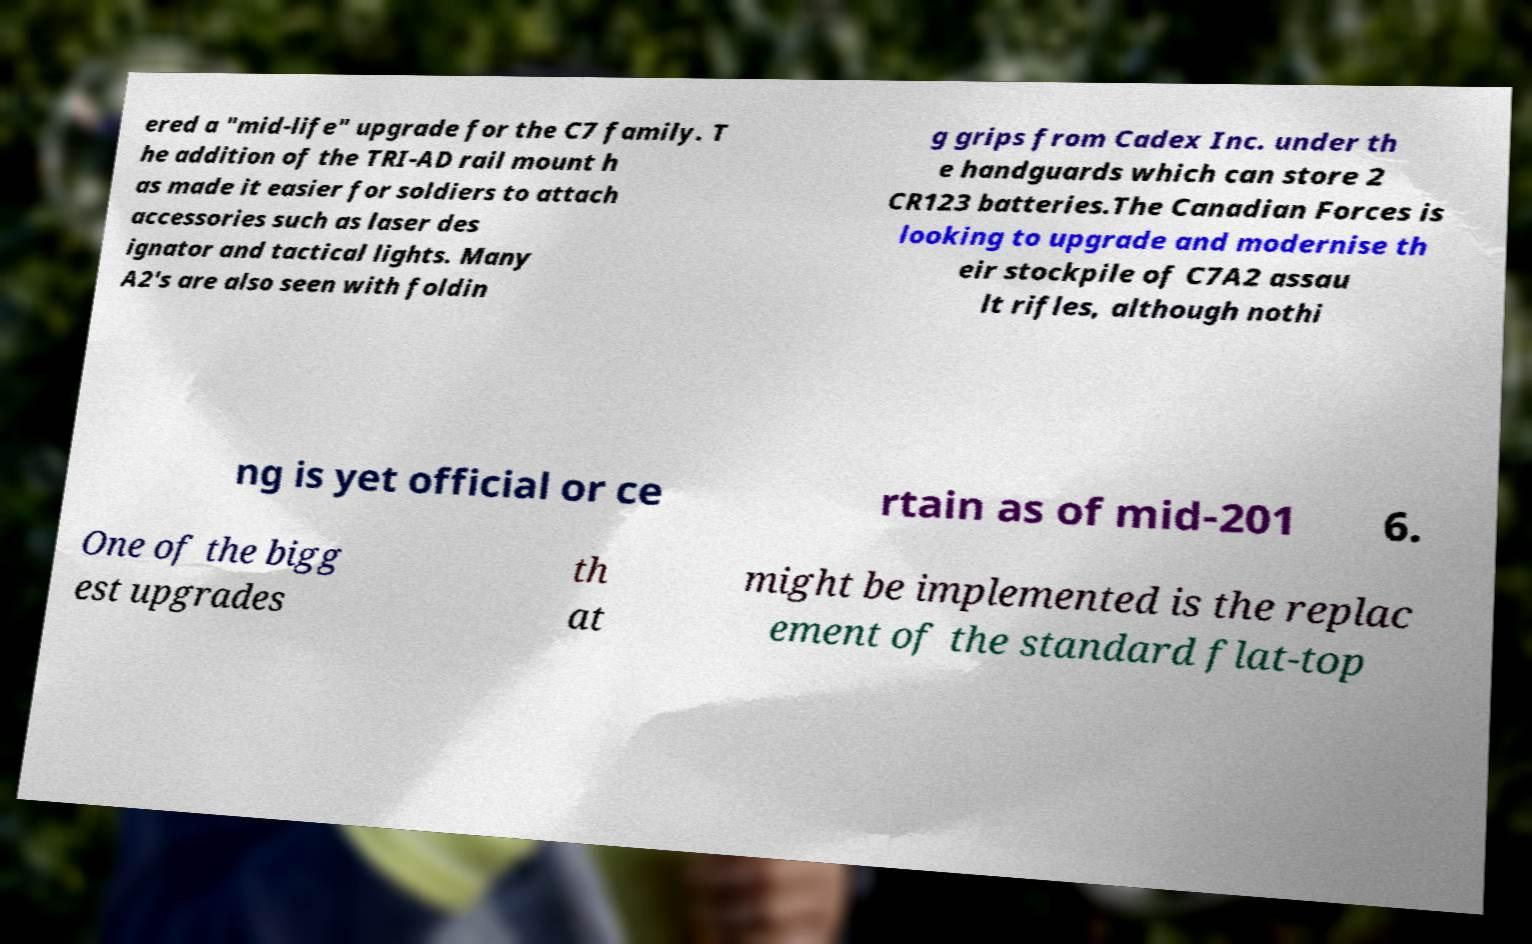For documentation purposes, I need the text within this image transcribed. Could you provide that? ered a "mid-life" upgrade for the C7 family. T he addition of the TRI-AD rail mount h as made it easier for soldiers to attach accessories such as laser des ignator and tactical lights. Many A2's are also seen with foldin g grips from Cadex Inc. under th e handguards which can store 2 CR123 batteries.The Canadian Forces is looking to upgrade and modernise th eir stockpile of C7A2 assau lt rifles, although nothi ng is yet official or ce rtain as of mid-201 6. One of the bigg est upgrades th at might be implemented is the replac ement of the standard flat-top 